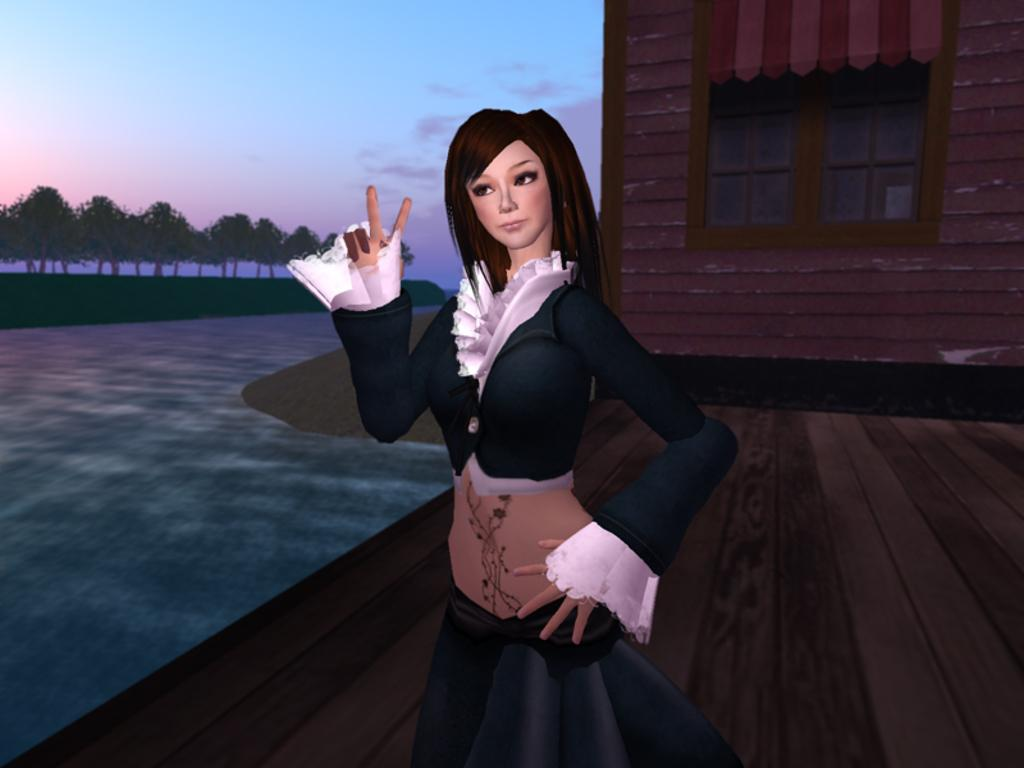What is the main subject of the image? The image contains an animated picture of a person. What can be seen in the background of the image? There is a building and many trees in the background of the image. What is visible in the sky in the background of the image? There are clouds in the sky in the background of the image. How much of the sky is visible in the background of the image? The sky is visible in the background of the image. What type of cent is visible in the image? There is no cent present in the image. What is the person in the image cooking? The image does not show the person cooking or any food items. 